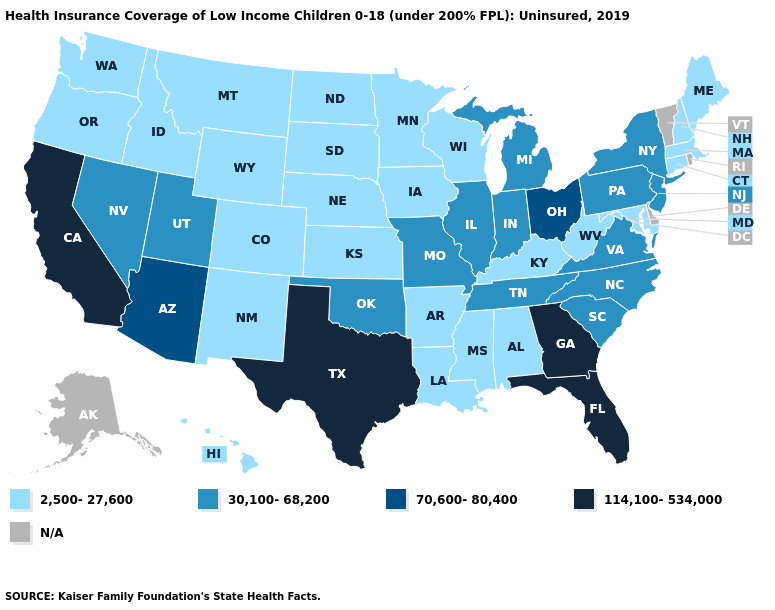Is the legend a continuous bar?
Concise answer only. No. What is the value of Washington?
Short answer required. 2,500-27,600. What is the value of Utah?
Be succinct. 30,100-68,200. Name the states that have a value in the range N/A?
Be succinct. Alaska, Delaware, Rhode Island, Vermont. Does Illinois have the lowest value in the MidWest?
Quick response, please. No. What is the value of Tennessee?
Be succinct. 30,100-68,200. Name the states that have a value in the range 114,100-534,000?
Give a very brief answer. California, Florida, Georgia, Texas. Is the legend a continuous bar?
Be succinct. No. Does Massachusetts have the lowest value in the Northeast?
Short answer required. Yes. Among the states that border Delaware , which have the highest value?
Short answer required. New Jersey, Pennsylvania. What is the highest value in the USA?
Give a very brief answer. 114,100-534,000. Name the states that have a value in the range 70,600-80,400?
Give a very brief answer. Arizona, Ohio. What is the value of Alabama?
Keep it brief. 2,500-27,600. 